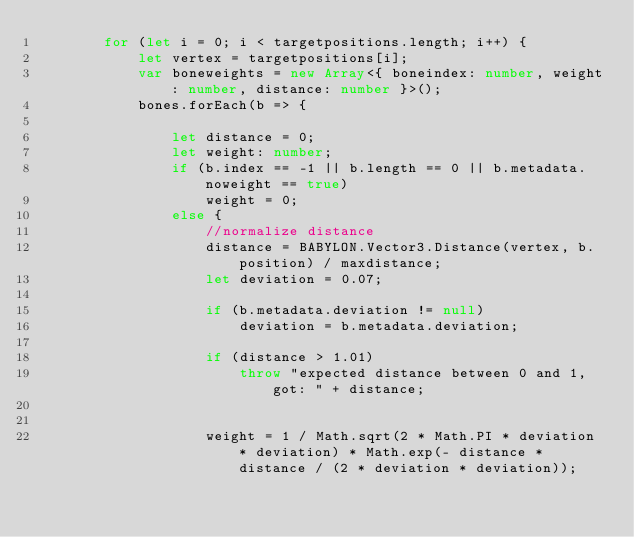<code> <loc_0><loc_0><loc_500><loc_500><_TypeScript_>        for (let i = 0; i < targetpositions.length; i++) {
            let vertex = targetpositions[i];
            var boneweights = new Array<{ boneindex: number, weight: number, distance: number }>();
            bones.forEach(b => {

                let distance = 0;
                let weight: number;
                if (b.index == -1 || b.length == 0 || b.metadata.noweight == true)
                    weight = 0;
                else {
                    //normalize distance
                    distance = BABYLON.Vector3.Distance(vertex, b.position) / maxdistance;
                    let deviation = 0.07;

                    if (b.metadata.deviation != null)
                        deviation = b.metadata.deviation;

                    if (distance > 1.01)
                        throw "expected distance between 0 and 1, got: " + distance;


                    weight = 1 / Math.sqrt(2 * Math.PI * deviation * deviation) * Math.exp(- distance * distance / (2 * deviation * deviation));
</code> 